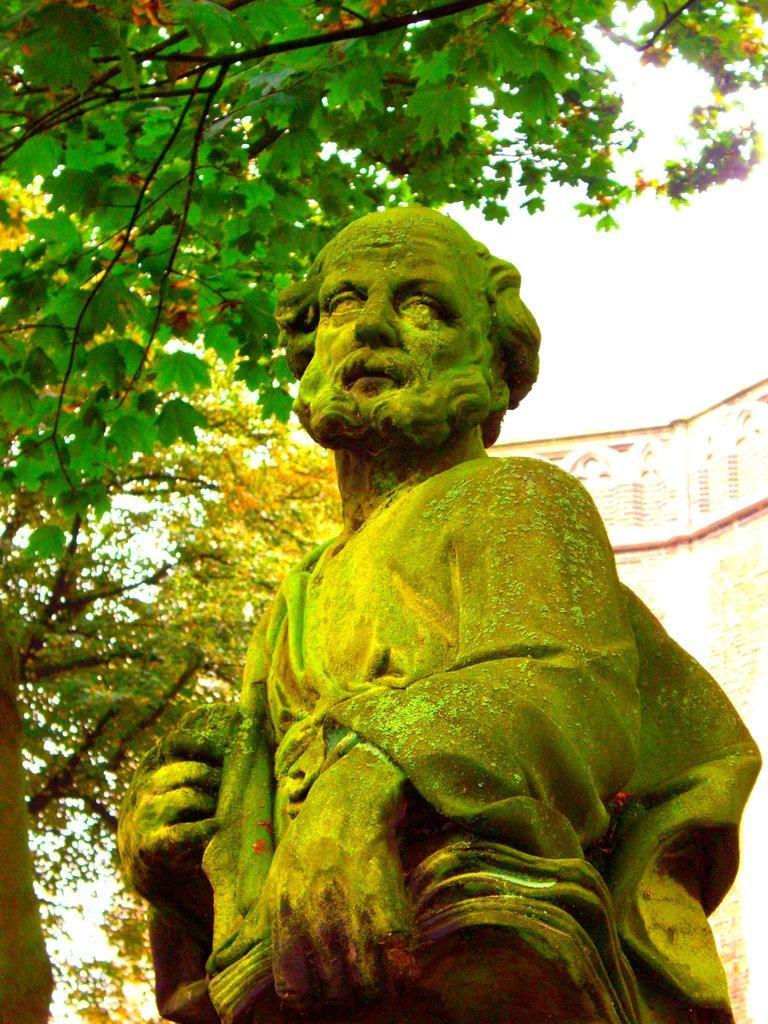In one or two sentences, can you explain what this image depicts? In this image I can see a statue. Background I can see trees in green color and sky in white color. 